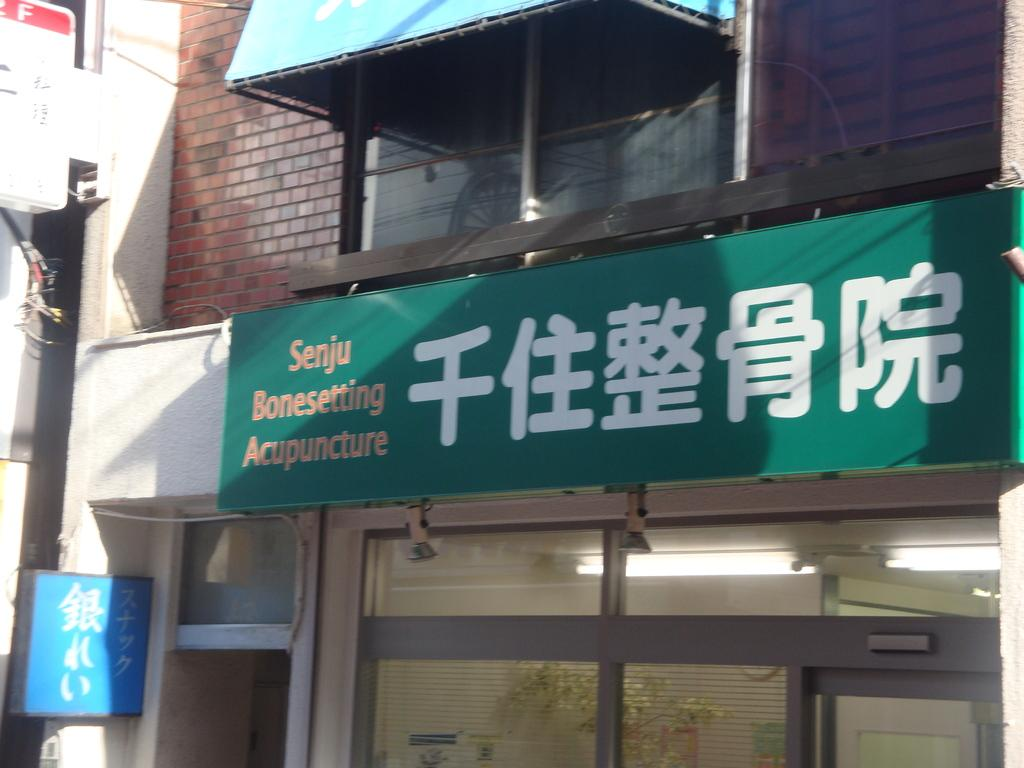What type of structure is shown in the image? The image shows a front view of a building. Is there any additional information displayed on the building? Yes, there is a banner attached to the building. What is the primary entrance to the building in the image? There is a door at the bottom of the image. Are there any other notable features on the left side of the building? Yes, there are two boards on the left side of the image. Can you tell me how many babies are inside the tent in the image? There is no tent or baby present in the image. What type of answer is written on the boards in the image? The provided facts do not mention any answers being written on the boards; they only mention the presence of two boards. 